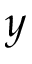Convert formula to latex. <formula><loc_0><loc_0><loc_500><loc_500>y</formula> 